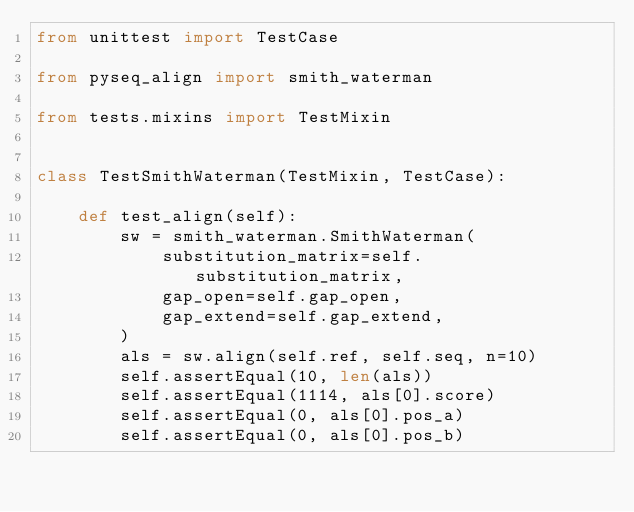Convert code to text. <code><loc_0><loc_0><loc_500><loc_500><_Python_>from unittest import TestCase

from pyseq_align import smith_waterman

from tests.mixins import TestMixin


class TestSmithWaterman(TestMixin, TestCase):

    def test_align(self):
        sw = smith_waterman.SmithWaterman(
            substitution_matrix=self.substitution_matrix,
            gap_open=self.gap_open,
            gap_extend=self.gap_extend,
        )
        als = sw.align(self.ref, self.seq, n=10)
        self.assertEqual(10, len(als))
        self.assertEqual(1114, als[0].score)
        self.assertEqual(0, als[0].pos_a)
        self.assertEqual(0, als[0].pos_b)
</code> 